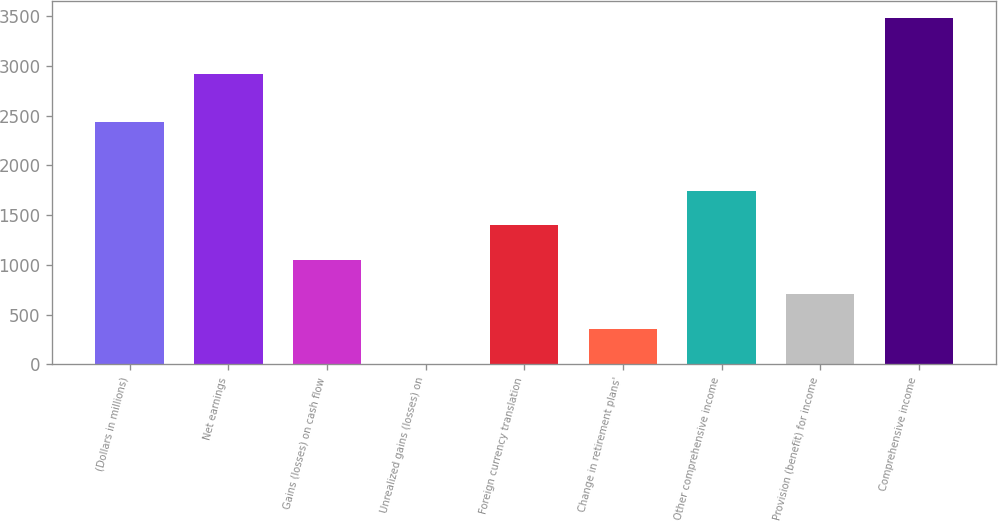<chart> <loc_0><loc_0><loc_500><loc_500><bar_chart><fcel>(Dollars in millions)<fcel>Net earnings<fcel>Gains (losses) on cash flow<fcel>Unrealized gains (losses) on<fcel>Foreign currency translation<fcel>Change in retirement plans'<fcel>Other comprehensive income<fcel>Provision (benefit) for income<fcel>Comprehensive income<nl><fcel>2438<fcel>2912<fcel>1050<fcel>9<fcel>1397<fcel>356<fcel>1744<fcel>703<fcel>3479<nl></chart> 